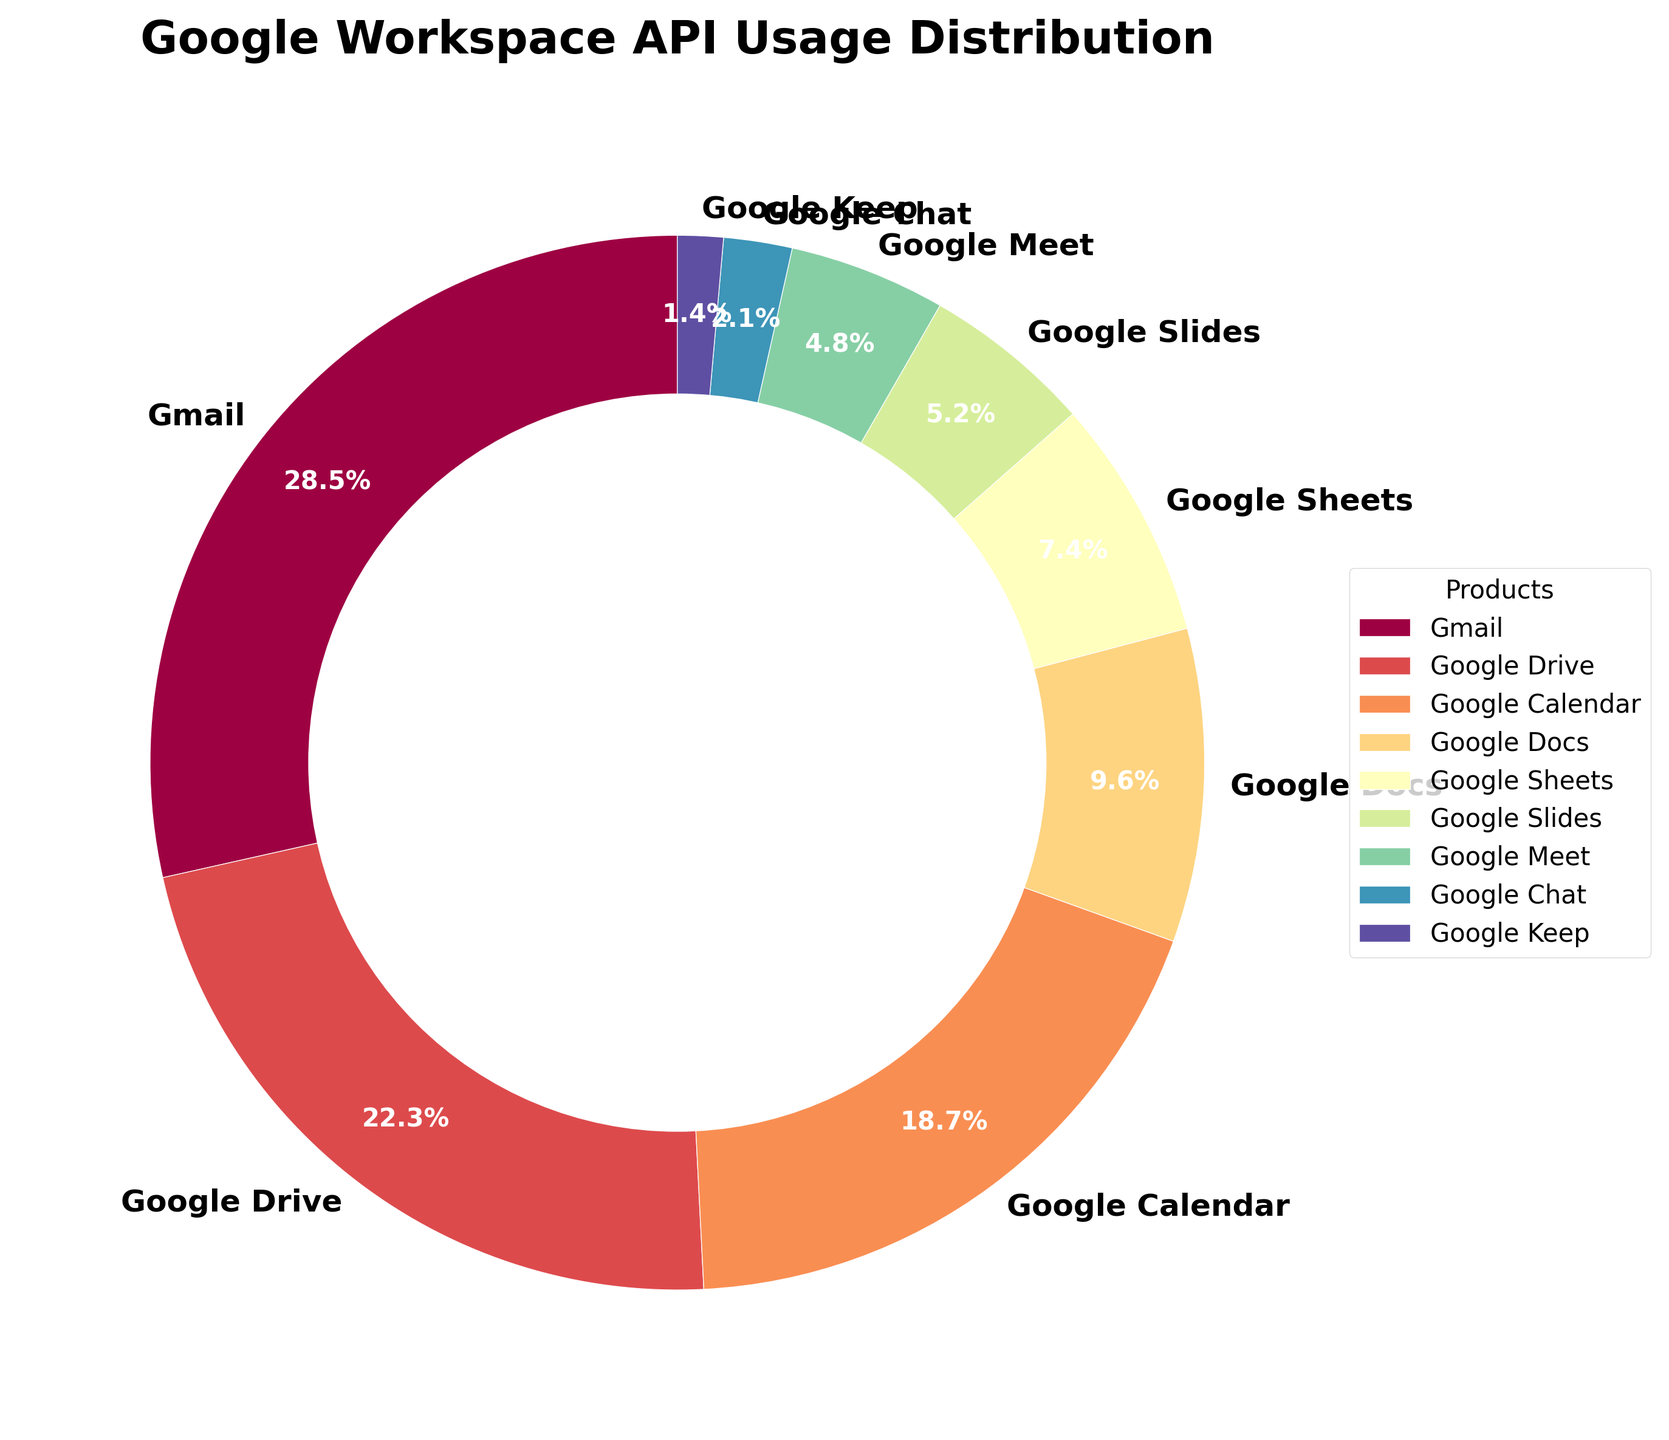What is the largest segment in the chart? The largest segment is identified by its size and label. "Gmail" has the highest percentage usage at 28.5%, making it the largest segment.
Answer: Gmail Which product has the smallest API usage percentage? The smallest segment is identified by its size and label. "Google Keep" has the lowest percentage usage at 1.4%, making it the smallest segment.
Answer: Google Keep How much larger is Gmail's API usage compared to Google Meet? First, find the difference between the two percentages. Gmail is 28.5% and Google Meet is 4.8%. The difference is 28.5% - 4.8% = 23.7%.
Answer: 23.7% What is the combined API usage percentage of Google Drive and Google Calendar? Add the percentages of Google Drive (22.3%) and Google Calendar (18.7%). The sum is 22.3% + 18.7% = 41%.
Answer: 41% Which two products have the most similar API usage percentages, and what are they? By comparing the segments, we find that Google Slides (5.2%) and Google Meet (4.8%) have the most similar percentages. The difference is 5.2% - 4.8% = 0.4%.
Answer: Google Slides and Google Meet Is the API usage of Google Sheets more than half of that of Google Docs? Compare the two values: Google Docs is 9.6% and Google Sheets is 7.4%. Half of Google Docs' usage is 9.6%/2 = 4.8%. Since 7.4% > 4.8%, Google Sheets' usage is more than half of Google Docs'.
Answer: Yes Which product has a higher API usage percentage, Google Calendar or Google Docs? Compare the two values: Google Calendar at 18.7% and Google Docs at 9.6%. Since 18.7% > 9.6%, Google Calendar has a higher usage percentage.
Answer: Google Calendar Which product has a higher API usage percentage, Google Slides or Google Chat? Compare the two values: Google Slides at 5.2% and Google Chat at 2.1%. Since 5.2% > 2.1%, Google Slides has a higher usage percentage.
Answer: Google Slides What is the sum of API usage percentages for the three least used products? Add the percentages of Google Chat (2.1%), Google Keep (1.4%), and Google Meet (4.8%). The sum is 2.1% + 1.4% + 4.8% = 8.3%.
Answer: 8.3% Is the total API usage of Gmail, Google Drive, and Google Calendar more than 50% of the total usage? Add the percentages of Gmail (28.5%), Google Drive (22.3%), and Google Calendar (18.7%). The sum is 28.5% + 22.3% + 18.7% = 69.5%. Since 69.5% > 50%, their combined usage is more than half of the total.
Answer: Yes 